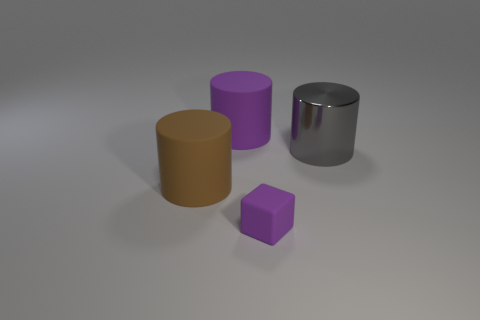Subtract all large gray metallic cylinders. How many cylinders are left? 2 Add 3 purple rubber cylinders. How many objects exist? 7 Subtract all cylinders. How many objects are left? 1 Add 4 large purple matte cylinders. How many large purple matte cylinders exist? 5 Subtract 0 yellow spheres. How many objects are left? 4 Subtract all brown rubber cylinders. Subtract all big brown cylinders. How many objects are left? 2 Add 1 gray things. How many gray things are left? 2 